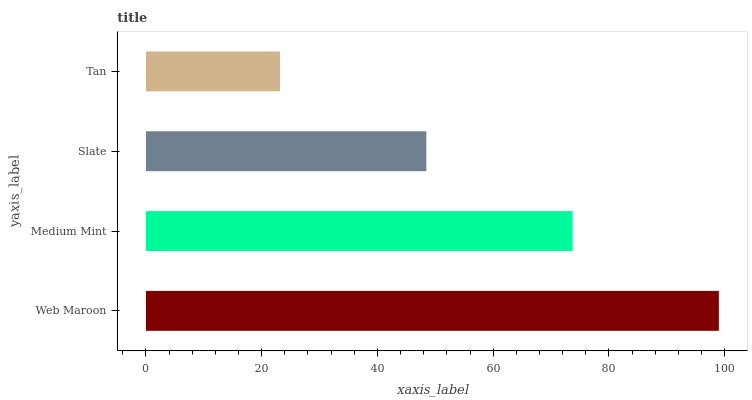Is Tan the minimum?
Answer yes or no. Yes. Is Web Maroon the maximum?
Answer yes or no. Yes. Is Medium Mint the minimum?
Answer yes or no. No. Is Medium Mint the maximum?
Answer yes or no. No. Is Web Maroon greater than Medium Mint?
Answer yes or no. Yes. Is Medium Mint less than Web Maroon?
Answer yes or no. Yes. Is Medium Mint greater than Web Maroon?
Answer yes or no. No. Is Web Maroon less than Medium Mint?
Answer yes or no. No. Is Medium Mint the high median?
Answer yes or no. Yes. Is Slate the low median?
Answer yes or no. Yes. Is Tan the high median?
Answer yes or no. No. Is Medium Mint the low median?
Answer yes or no. No. 